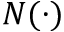<formula> <loc_0><loc_0><loc_500><loc_500>N ( \cdot )</formula> 